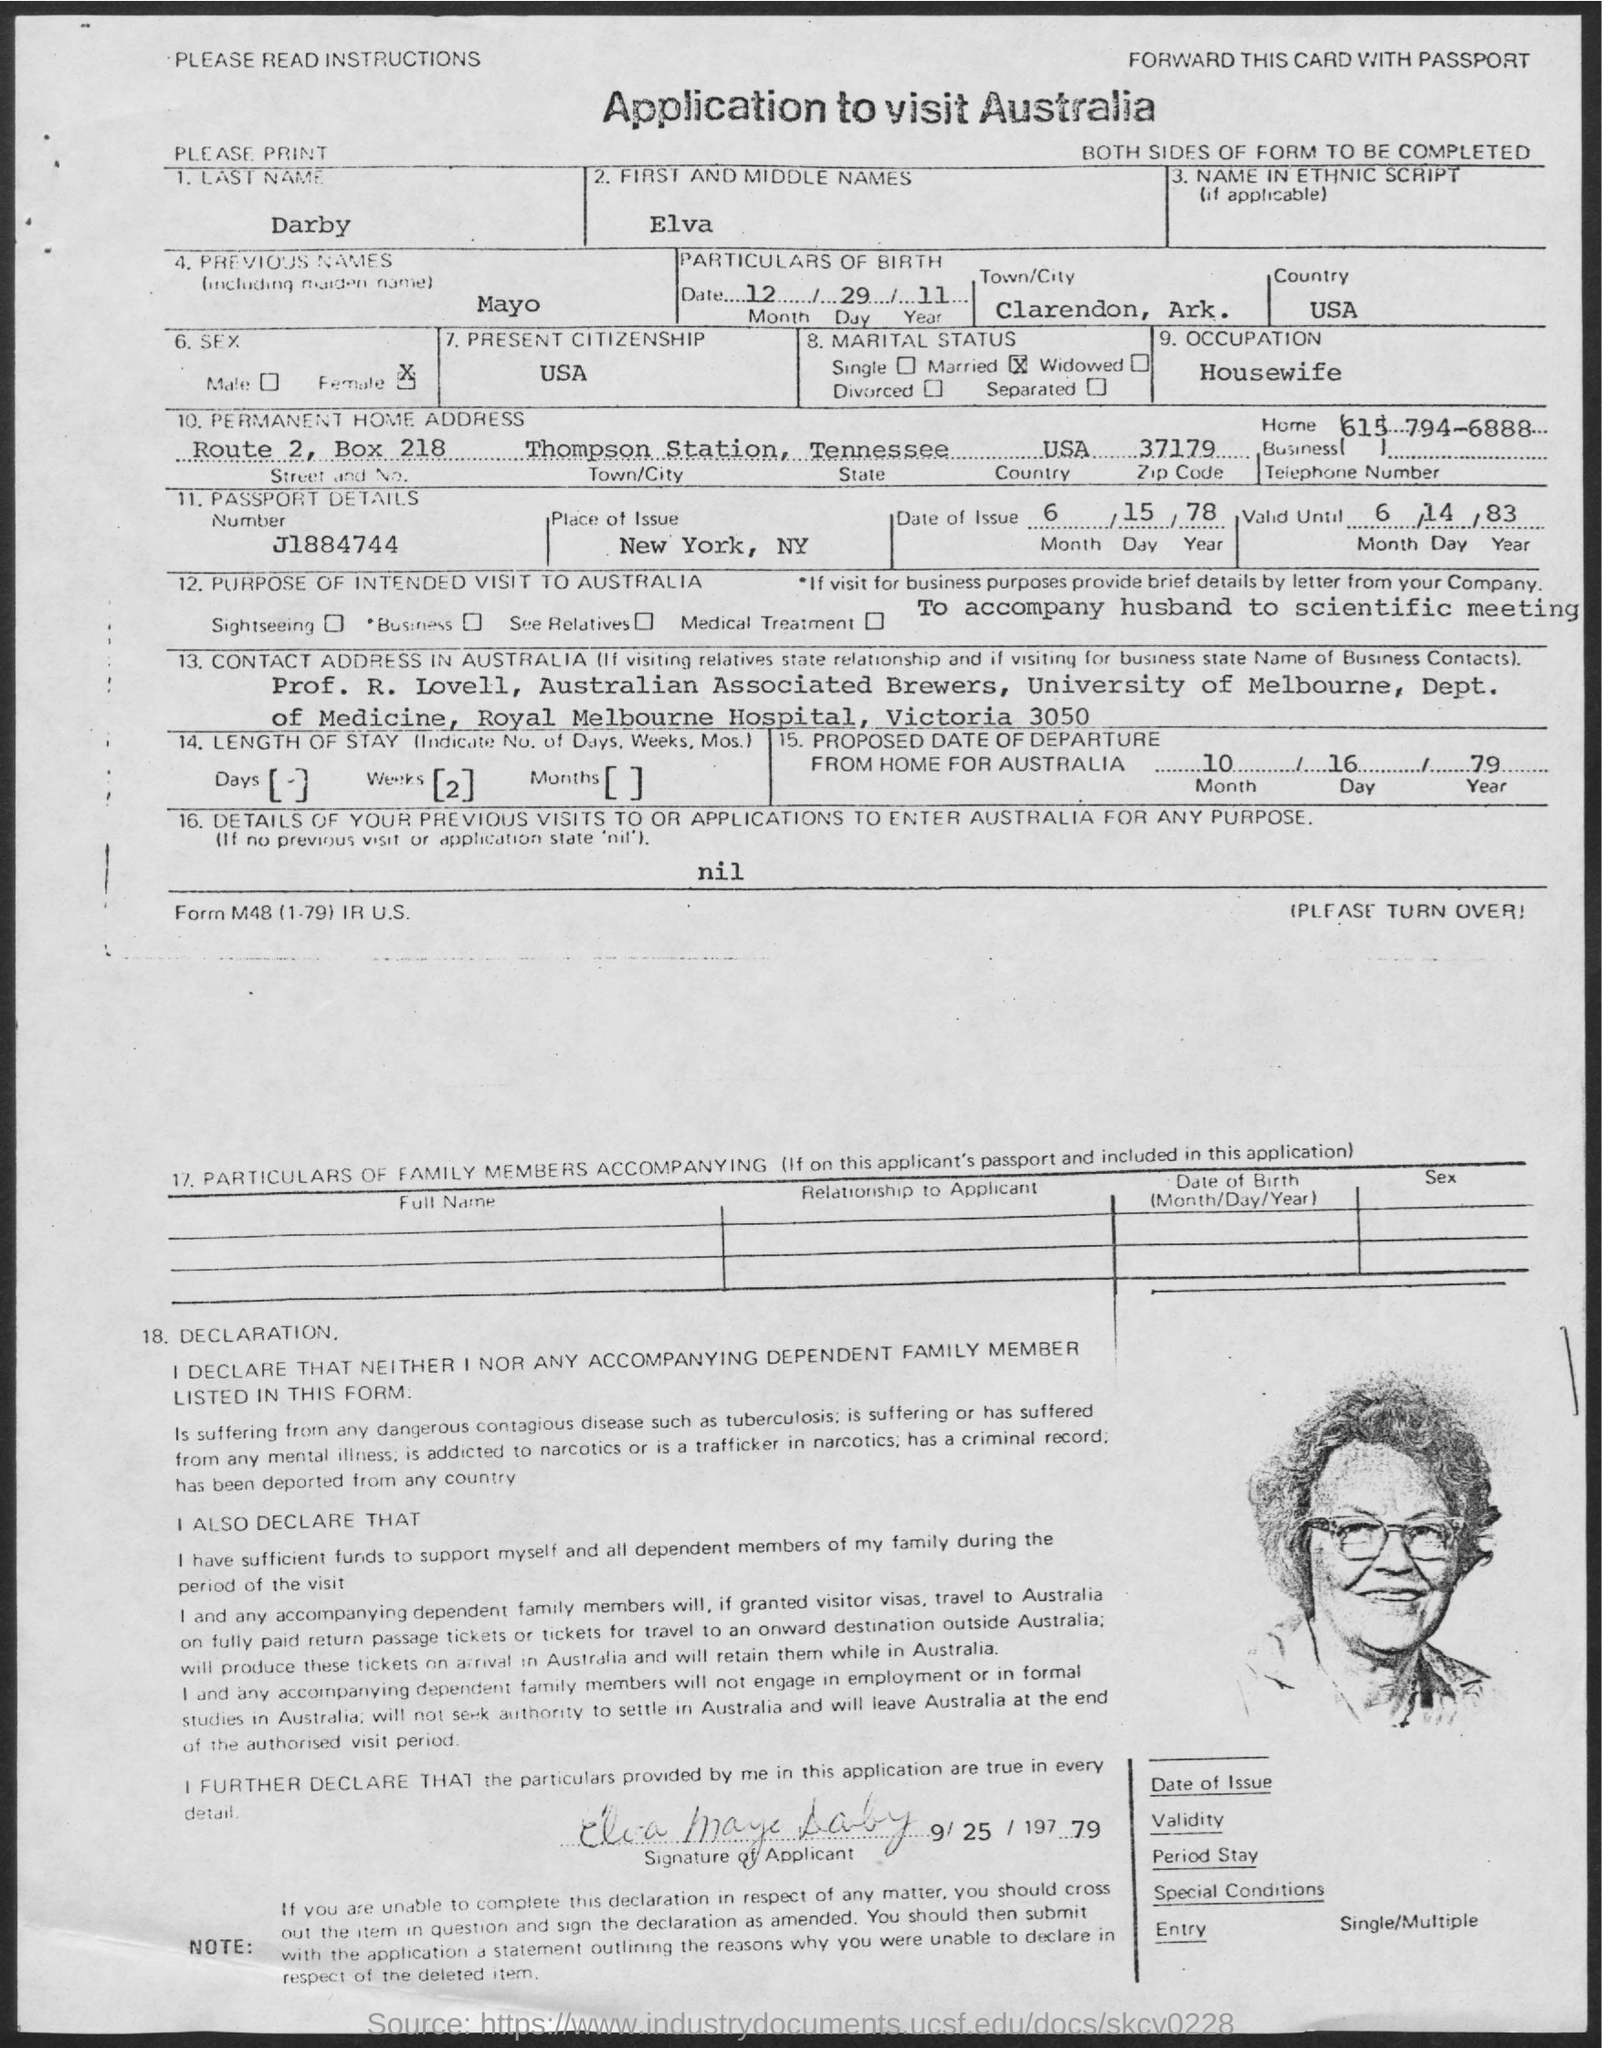Indicate a few pertinent items in this graphic. What is the Box Number? It is 218. What is your date of birth? December 29, 2011. The passport details number is J1884744... Elva is a housewife. The last name of the applicant is Darby. 